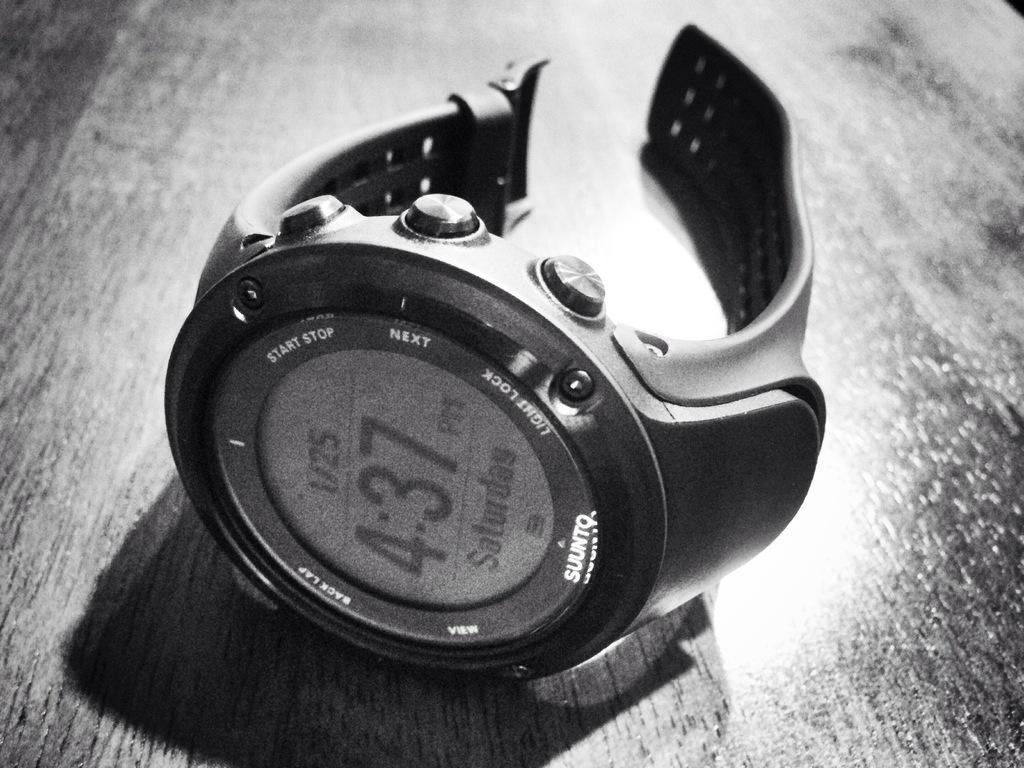<image>
Create a compact narrative representing the image presented. A digital watch made by Sunnto on its side 